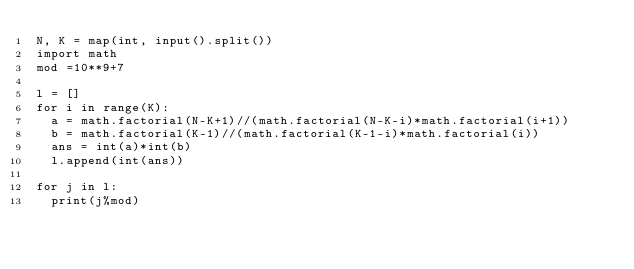Convert code to text. <code><loc_0><loc_0><loc_500><loc_500><_Python_>N, K = map(int, input().split())
import math
mod =10**9+7

l = []
for i in range(K):
  a = math.factorial(N-K+1)//(math.factorial(N-K-i)*math.factorial(i+1))
  b = math.factorial(K-1)//(math.factorial(K-1-i)*math.factorial(i))
  ans = int(a)*int(b)
  l.append(int(ans))

for j in l:
  print(j%mod)
</code> 